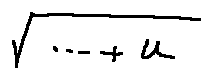Convert formula to latex. <formula><loc_0><loc_0><loc_500><loc_500>\sqrt { \cdots + u }</formula> 